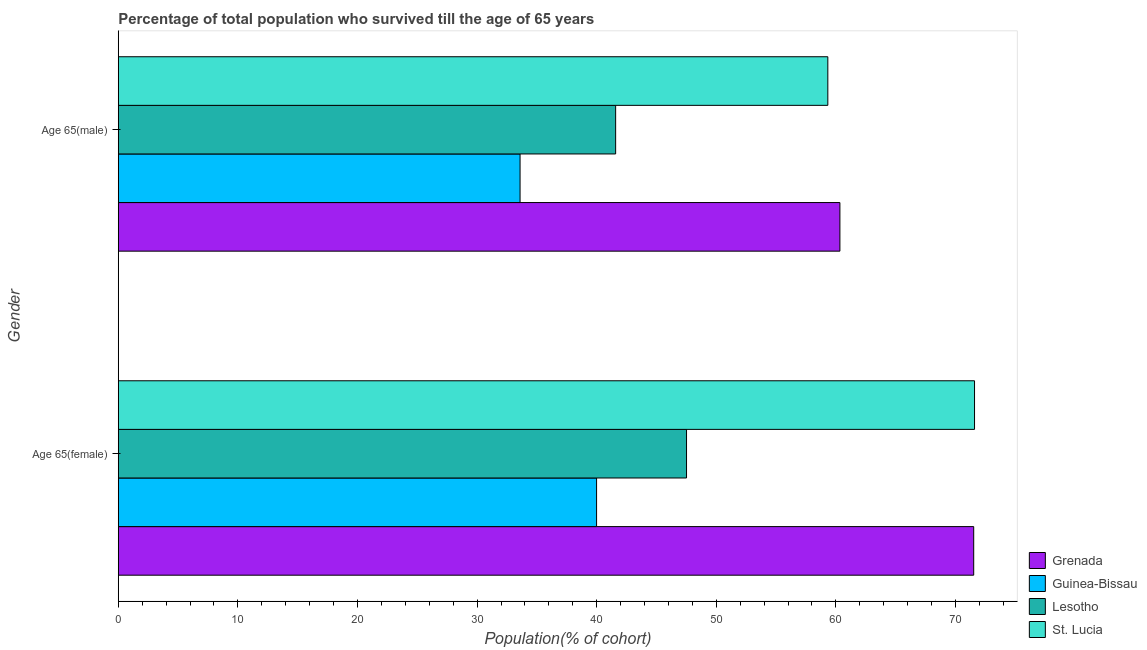How many bars are there on the 1st tick from the top?
Keep it short and to the point. 4. What is the label of the 2nd group of bars from the top?
Keep it short and to the point. Age 65(female). What is the percentage of female population who survived till age of 65 in Guinea-Bissau?
Your answer should be compact. 39.99. Across all countries, what is the maximum percentage of male population who survived till age of 65?
Make the answer very short. 60.34. Across all countries, what is the minimum percentage of female population who survived till age of 65?
Your response must be concise. 39.99. In which country was the percentage of female population who survived till age of 65 maximum?
Offer a very short reply. St. Lucia. In which country was the percentage of male population who survived till age of 65 minimum?
Your response must be concise. Guinea-Bissau. What is the total percentage of male population who survived till age of 65 in the graph?
Keep it short and to the point. 194.84. What is the difference between the percentage of male population who survived till age of 65 in Grenada and that in Lesotho?
Provide a succinct answer. 18.75. What is the difference between the percentage of male population who survived till age of 65 in Guinea-Bissau and the percentage of female population who survived till age of 65 in St. Lucia?
Keep it short and to the point. -38. What is the average percentage of male population who survived till age of 65 per country?
Offer a terse response. 48.71. What is the difference between the percentage of male population who survived till age of 65 and percentage of female population who survived till age of 65 in Grenada?
Make the answer very short. -11.19. What is the ratio of the percentage of male population who survived till age of 65 in Grenada to that in Lesotho?
Your answer should be very brief. 1.45. What does the 2nd bar from the top in Age 65(female) represents?
Provide a short and direct response. Lesotho. What does the 4th bar from the bottom in Age 65(male) represents?
Your answer should be compact. St. Lucia. How many countries are there in the graph?
Your answer should be compact. 4. How many legend labels are there?
Make the answer very short. 4. What is the title of the graph?
Your answer should be compact. Percentage of total population who survived till the age of 65 years. Does "Madagascar" appear as one of the legend labels in the graph?
Offer a terse response. No. What is the label or title of the X-axis?
Offer a terse response. Population(% of cohort). What is the Population(% of cohort) of Grenada in Age 65(female)?
Your answer should be compact. 71.52. What is the Population(% of cohort) of Guinea-Bissau in Age 65(female)?
Offer a very short reply. 39.99. What is the Population(% of cohort) in Lesotho in Age 65(female)?
Your response must be concise. 47.51. What is the Population(% of cohort) of St. Lucia in Age 65(female)?
Your answer should be compact. 71.59. What is the Population(% of cohort) of Grenada in Age 65(male)?
Your answer should be very brief. 60.34. What is the Population(% of cohort) of Guinea-Bissau in Age 65(male)?
Provide a short and direct response. 33.59. What is the Population(% of cohort) in Lesotho in Age 65(male)?
Give a very brief answer. 41.58. What is the Population(% of cohort) of St. Lucia in Age 65(male)?
Your response must be concise. 59.33. Across all Gender, what is the maximum Population(% of cohort) of Grenada?
Ensure brevity in your answer.  71.52. Across all Gender, what is the maximum Population(% of cohort) of Guinea-Bissau?
Your answer should be compact. 39.99. Across all Gender, what is the maximum Population(% of cohort) in Lesotho?
Your response must be concise. 47.51. Across all Gender, what is the maximum Population(% of cohort) in St. Lucia?
Ensure brevity in your answer.  71.59. Across all Gender, what is the minimum Population(% of cohort) of Grenada?
Provide a succinct answer. 60.34. Across all Gender, what is the minimum Population(% of cohort) of Guinea-Bissau?
Keep it short and to the point. 33.59. Across all Gender, what is the minimum Population(% of cohort) of Lesotho?
Keep it short and to the point. 41.58. Across all Gender, what is the minimum Population(% of cohort) of St. Lucia?
Your answer should be very brief. 59.33. What is the total Population(% of cohort) in Grenada in the graph?
Offer a terse response. 131.86. What is the total Population(% of cohort) in Guinea-Bissau in the graph?
Provide a succinct answer. 73.58. What is the total Population(% of cohort) of Lesotho in the graph?
Provide a short and direct response. 89.1. What is the total Population(% of cohort) in St. Lucia in the graph?
Ensure brevity in your answer.  130.92. What is the difference between the Population(% of cohort) of Grenada in Age 65(female) and that in Age 65(male)?
Offer a very short reply. 11.19. What is the difference between the Population(% of cohort) in Guinea-Bissau in Age 65(female) and that in Age 65(male)?
Provide a short and direct response. 6.4. What is the difference between the Population(% of cohort) in Lesotho in Age 65(female) and that in Age 65(male)?
Offer a terse response. 5.93. What is the difference between the Population(% of cohort) of St. Lucia in Age 65(female) and that in Age 65(male)?
Offer a terse response. 12.27. What is the difference between the Population(% of cohort) of Grenada in Age 65(female) and the Population(% of cohort) of Guinea-Bissau in Age 65(male)?
Give a very brief answer. 37.93. What is the difference between the Population(% of cohort) in Grenada in Age 65(female) and the Population(% of cohort) in Lesotho in Age 65(male)?
Offer a terse response. 29.94. What is the difference between the Population(% of cohort) of Grenada in Age 65(female) and the Population(% of cohort) of St. Lucia in Age 65(male)?
Your answer should be very brief. 12.2. What is the difference between the Population(% of cohort) of Guinea-Bissau in Age 65(female) and the Population(% of cohort) of Lesotho in Age 65(male)?
Offer a terse response. -1.59. What is the difference between the Population(% of cohort) in Guinea-Bissau in Age 65(female) and the Population(% of cohort) in St. Lucia in Age 65(male)?
Give a very brief answer. -19.33. What is the difference between the Population(% of cohort) of Lesotho in Age 65(female) and the Population(% of cohort) of St. Lucia in Age 65(male)?
Give a very brief answer. -11.81. What is the average Population(% of cohort) in Grenada per Gender?
Make the answer very short. 65.93. What is the average Population(% of cohort) of Guinea-Bissau per Gender?
Your answer should be compact. 36.79. What is the average Population(% of cohort) of Lesotho per Gender?
Offer a terse response. 44.55. What is the average Population(% of cohort) in St. Lucia per Gender?
Make the answer very short. 65.46. What is the difference between the Population(% of cohort) of Grenada and Population(% of cohort) of Guinea-Bissau in Age 65(female)?
Your response must be concise. 31.53. What is the difference between the Population(% of cohort) of Grenada and Population(% of cohort) of Lesotho in Age 65(female)?
Provide a short and direct response. 24.01. What is the difference between the Population(% of cohort) in Grenada and Population(% of cohort) in St. Lucia in Age 65(female)?
Keep it short and to the point. -0.07. What is the difference between the Population(% of cohort) in Guinea-Bissau and Population(% of cohort) in Lesotho in Age 65(female)?
Ensure brevity in your answer.  -7.52. What is the difference between the Population(% of cohort) in Guinea-Bissau and Population(% of cohort) in St. Lucia in Age 65(female)?
Your response must be concise. -31.6. What is the difference between the Population(% of cohort) of Lesotho and Population(% of cohort) of St. Lucia in Age 65(female)?
Provide a succinct answer. -24.08. What is the difference between the Population(% of cohort) of Grenada and Population(% of cohort) of Guinea-Bissau in Age 65(male)?
Offer a very short reply. 26.74. What is the difference between the Population(% of cohort) in Grenada and Population(% of cohort) in Lesotho in Age 65(male)?
Provide a succinct answer. 18.75. What is the difference between the Population(% of cohort) in Grenada and Population(% of cohort) in St. Lucia in Age 65(male)?
Your response must be concise. 1.01. What is the difference between the Population(% of cohort) in Guinea-Bissau and Population(% of cohort) in Lesotho in Age 65(male)?
Your answer should be very brief. -7.99. What is the difference between the Population(% of cohort) of Guinea-Bissau and Population(% of cohort) of St. Lucia in Age 65(male)?
Your answer should be compact. -25.73. What is the difference between the Population(% of cohort) in Lesotho and Population(% of cohort) in St. Lucia in Age 65(male)?
Your response must be concise. -17.74. What is the ratio of the Population(% of cohort) of Grenada in Age 65(female) to that in Age 65(male)?
Give a very brief answer. 1.19. What is the ratio of the Population(% of cohort) in Guinea-Bissau in Age 65(female) to that in Age 65(male)?
Your answer should be very brief. 1.19. What is the ratio of the Population(% of cohort) of Lesotho in Age 65(female) to that in Age 65(male)?
Your answer should be very brief. 1.14. What is the ratio of the Population(% of cohort) in St. Lucia in Age 65(female) to that in Age 65(male)?
Keep it short and to the point. 1.21. What is the difference between the highest and the second highest Population(% of cohort) of Grenada?
Your answer should be very brief. 11.19. What is the difference between the highest and the second highest Population(% of cohort) of Guinea-Bissau?
Give a very brief answer. 6.4. What is the difference between the highest and the second highest Population(% of cohort) in Lesotho?
Offer a very short reply. 5.93. What is the difference between the highest and the second highest Population(% of cohort) in St. Lucia?
Offer a terse response. 12.27. What is the difference between the highest and the lowest Population(% of cohort) of Grenada?
Ensure brevity in your answer.  11.19. What is the difference between the highest and the lowest Population(% of cohort) in Guinea-Bissau?
Your response must be concise. 6.4. What is the difference between the highest and the lowest Population(% of cohort) of Lesotho?
Provide a succinct answer. 5.93. What is the difference between the highest and the lowest Population(% of cohort) of St. Lucia?
Your answer should be very brief. 12.27. 